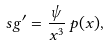<formula> <loc_0><loc_0><loc_500><loc_500>\ s g ^ { \prime } = \frac { \psi } { x ^ { 3 } } \, p ( x ) ,</formula> 